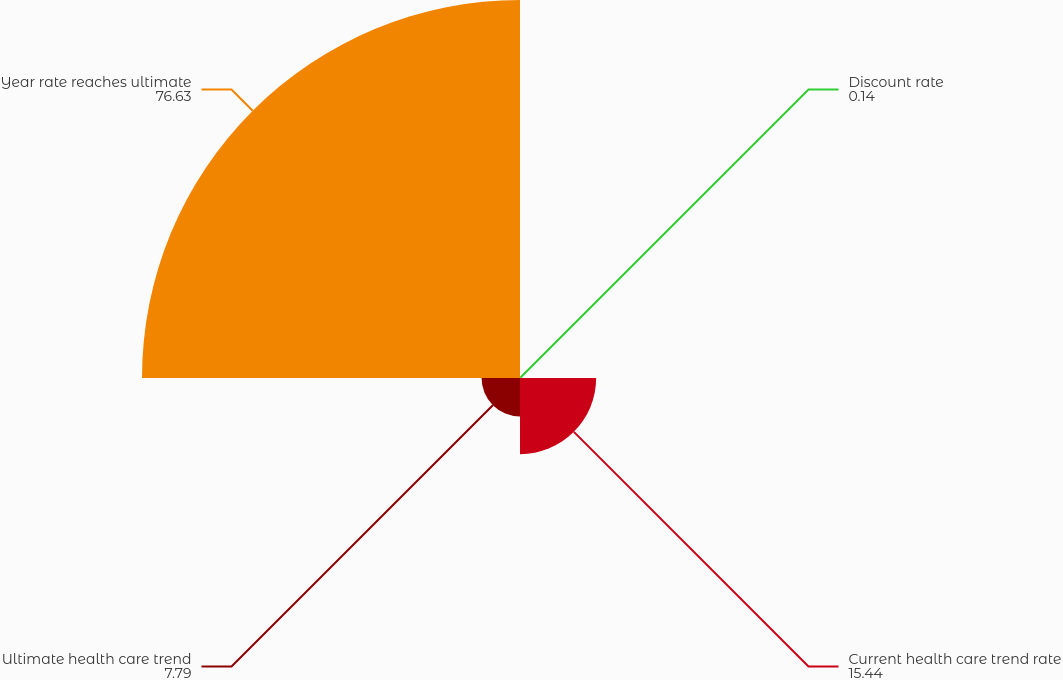<chart> <loc_0><loc_0><loc_500><loc_500><pie_chart><fcel>Discount rate<fcel>Current health care trend rate<fcel>Ultimate health care trend<fcel>Year rate reaches ultimate<nl><fcel>0.14%<fcel>15.44%<fcel>7.79%<fcel>76.63%<nl></chart> 